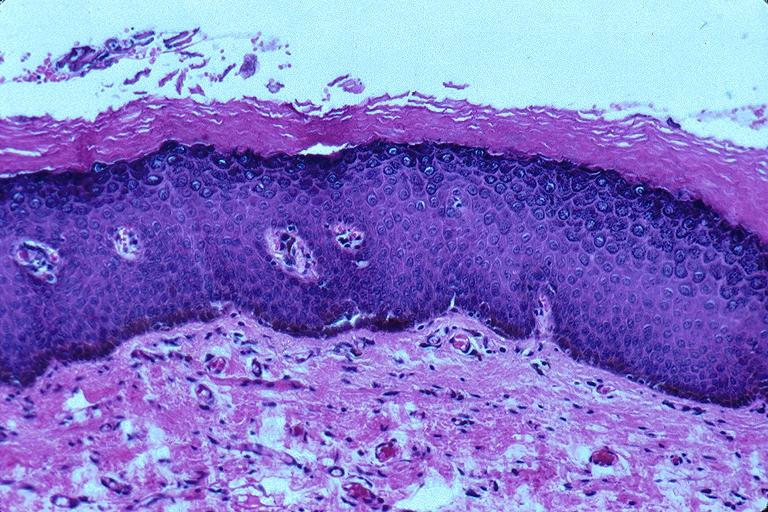what does this image show?
Answer the question using a single word or phrase. Epithelial hyperplasia and hyperkeratosis 